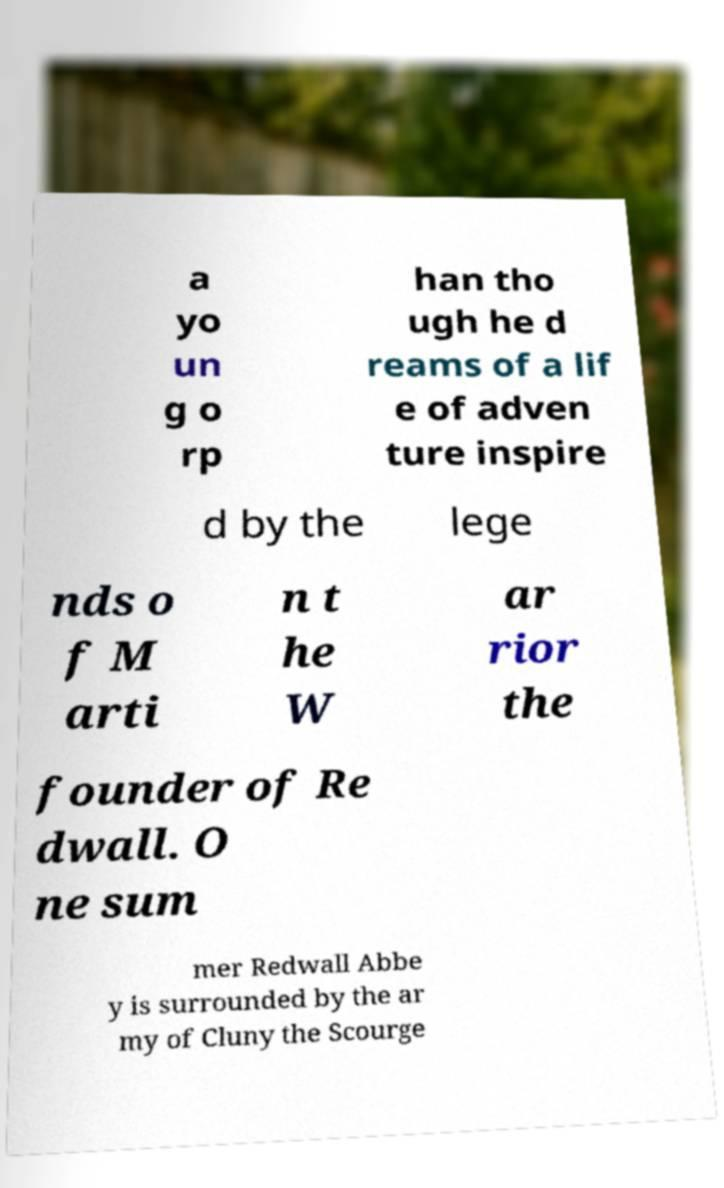Could you assist in decoding the text presented in this image and type it out clearly? a yo un g o rp han tho ugh he d reams of a lif e of adven ture inspire d by the lege nds o f M arti n t he W ar rior the founder of Re dwall. O ne sum mer Redwall Abbe y is surrounded by the ar my of Cluny the Scourge 